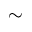Convert formula to latex. <formula><loc_0><loc_0><loc_500><loc_500>\sim</formula> 